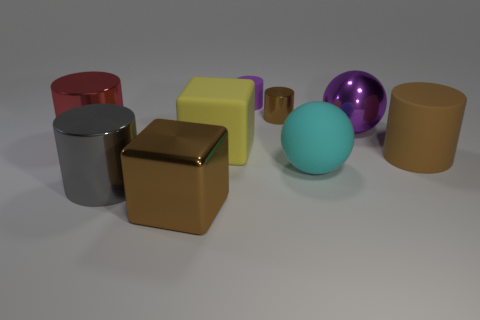Subtract all tiny brown shiny cylinders. How many cylinders are left? 4 Subtract all yellow blocks. How many blocks are left? 1 Subtract 2 cylinders. How many cylinders are left? 3 Subtract all cylinders. How many objects are left? 4 Subtract all green cubes. Subtract all brown spheres. How many cubes are left? 2 Subtract all blue cubes. How many brown cylinders are left? 2 Subtract all tiny yellow cylinders. Subtract all big yellow things. How many objects are left? 8 Add 4 small rubber things. How many small rubber things are left? 5 Add 7 purple shiny things. How many purple shiny things exist? 8 Subtract 0 red blocks. How many objects are left? 9 